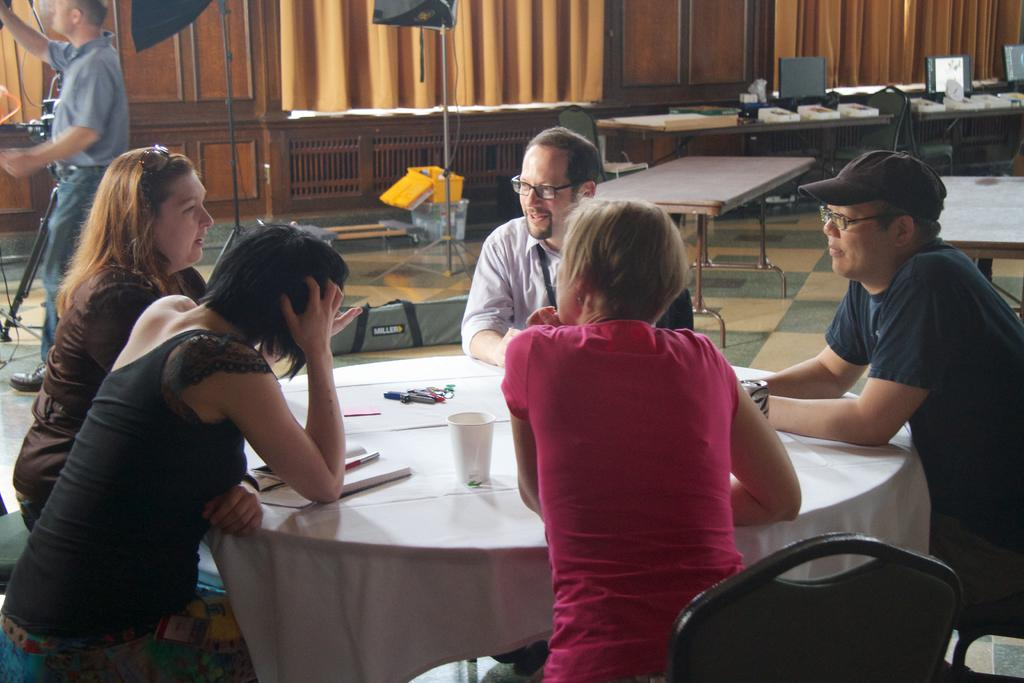What is happening in the image? There is a group of people in the image, and they are sitting near a table. What are the people doing while sitting near the table? The people are talking with each other. What type of flag is being cut with scissors in the wilderness? There is no flag or scissors present in the image, and the scene is not set in the wilderness. 